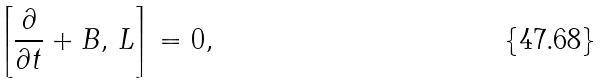<formula> <loc_0><loc_0><loc_500><loc_500>\left [ \frac { \partial } { \partial t } + B , \, L \right ] = 0 ,</formula> 